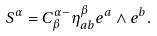<formula> <loc_0><loc_0><loc_500><loc_500>S ^ { \alpha } = C _ { \beta } ^ { \alpha - } \eta _ { a b } ^ { \beta } e ^ { a } \wedge e ^ { b } .</formula> 